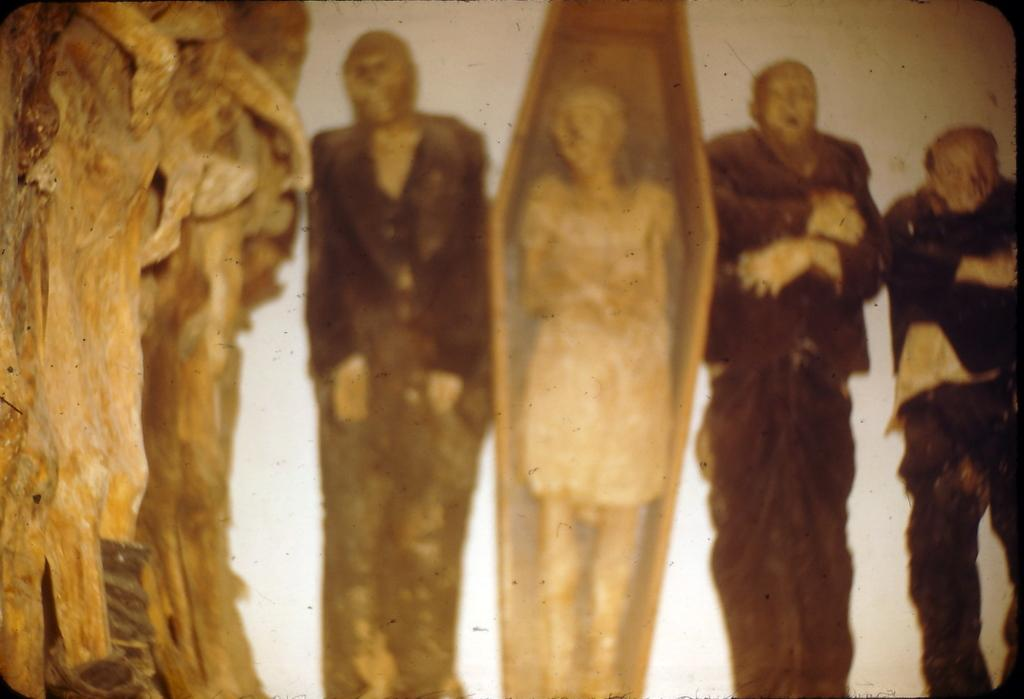What is the main subject of the image? There is a painting in the image. What is happening in the painting? The painting depicts three men lying down and a lady lying in a box. Are there any other art pieces visible in the image? Yes, there is a sculpture on the left side of the image. Can you read the writing on the receipt in the image? There is no receipt present in the image, so there is no writing to read. 